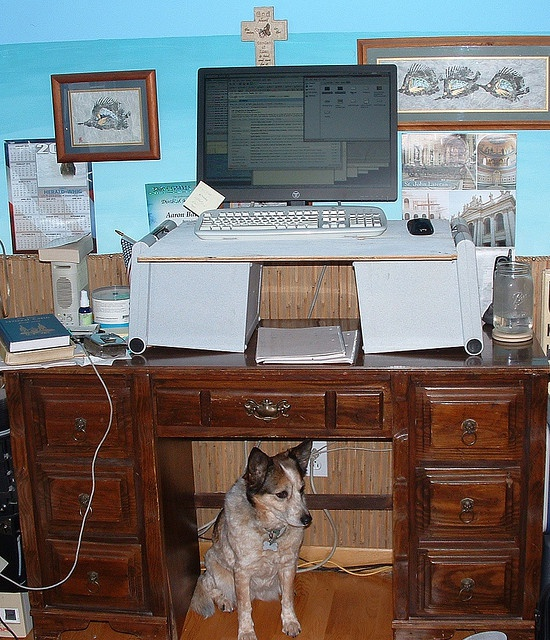Describe the objects in this image and their specific colors. I can see tv in lightblue, gray, black, purple, and darkblue tones, dog in lightblue, darkgray, gray, and black tones, keyboard in lightblue, lightgray, darkgray, and gray tones, and mouse in lightblue, black, gray, navy, and purple tones in this image. 